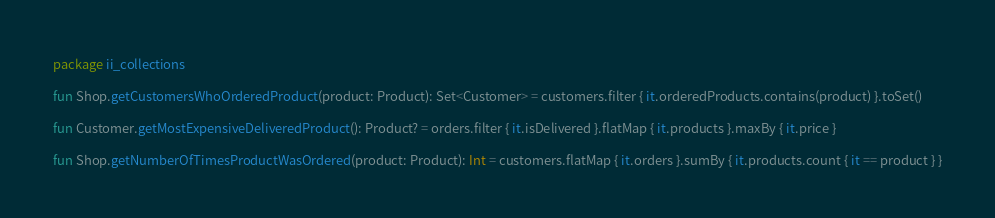Convert code to text. <code><loc_0><loc_0><loc_500><loc_500><_Kotlin_>package ii_collections

fun Shop.getCustomersWhoOrderedProduct(product: Product): Set<Customer> = customers.filter { it.orderedProducts.contains(product) }.toSet()

fun Customer.getMostExpensiveDeliveredProduct(): Product? = orders.filter { it.isDelivered }.flatMap { it.products }.maxBy { it.price }

fun Shop.getNumberOfTimesProductWasOrdered(product: Product): Int = customers.flatMap { it.orders }.sumBy { it.products.count { it == product } }
</code> 